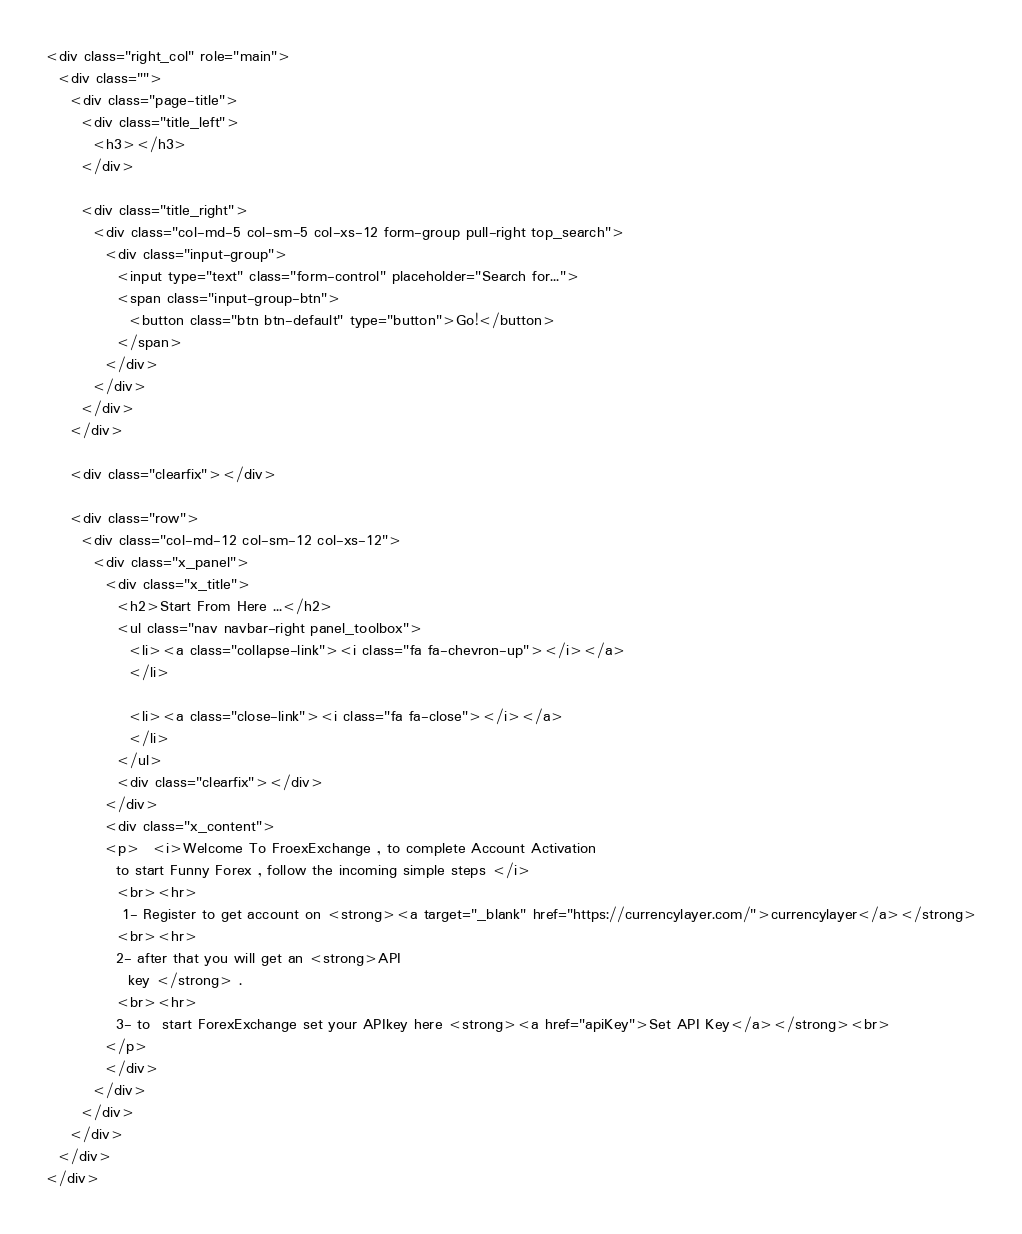<code> <loc_0><loc_0><loc_500><loc_500><_PHP_><div class="right_col" role="main">
  <div class="">
    <div class="page-title">
      <div class="title_left">
        <h3></h3>
      </div>

      <div class="title_right">
        <div class="col-md-5 col-sm-5 col-xs-12 form-group pull-right top_search">
          <div class="input-group">
            <input type="text" class="form-control" placeholder="Search for...">
            <span class="input-group-btn">
              <button class="btn btn-default" type="button">Go!</button>
            </span>
          </div>
        </div>
      </div>
    </div>

    <div class="clearfix"></div>

    <div class="row">
      <div class="col-md-12 col-sm-12 col-xs-12">
        <div class="x_panel">
          <div class="x_title">
            <h2>Start From Here ...</h2>
            <ul class="nav navbar-right panel_toolbox">
              <li><a class="collapse-link"><i class="fa fa-chevron-up"></i></a>
              </li>

              <li><a class="close-link"><i class="fa fa-close"></i></a>
              </li>
            </ul>
            <div class="clearfix"></div>
          </div>
          <div class="x_content">
          <p>  <i>Welcome To FroexExchange , to complete Account Activation
            to start Funny Forex , follow the incoming simple steps </i>
            <br><hr>
             1- Register to get account on <strong><a target="_blank" href="https://currencylayer.com/">currencylayer</a></strong>
            <br><hr>
            2- after that you will get an <strong>API
              key </strong> .
            <br><hr>
            3- to  start ForexExchange set your APIkey here <strong><a href="apiKey">Set API Key</a></strong><br>
          </p>
          </div>
        </div>
      </div>
    </div>
  </div>
</div>
</code> 